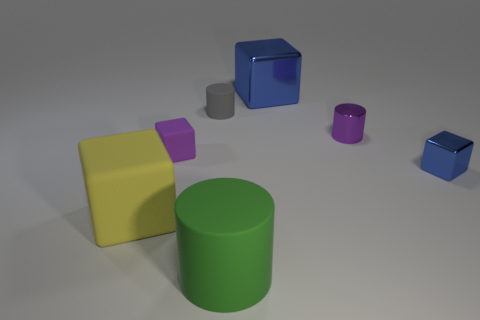Subtract all large cylinders. How many cylinders are left? 2 Subtract 2 cylinders. How many cylinders are left? 1 Add 2 large yellow cubes. How many objects exist? 9 Subtract all purple blocks. How many blocks are left? 3 Add 6 tiny blocks. How many tiny blocks exist? 8 Subtract 0 blue cylinders. How many objects are left? 7 Subtract all cubes. How many objects are left? 3 Subtract all blue cubes. Subtract all cyan cylinders. How many cubes are left? 2 Subtract all cyan spheres. How many red cylinders are left? 0 Subtract all big blue metallic cubes. Subtract all big matte blocks. How many objects are left? 5 